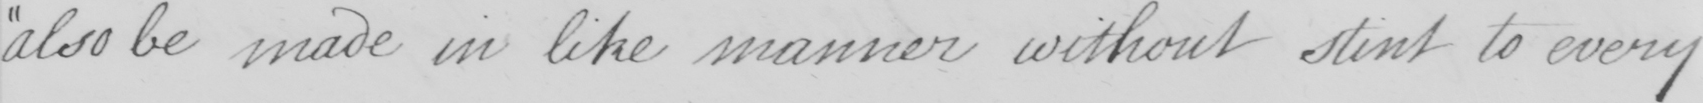What does this handwritten line say? also be made in like manner without stint to every 